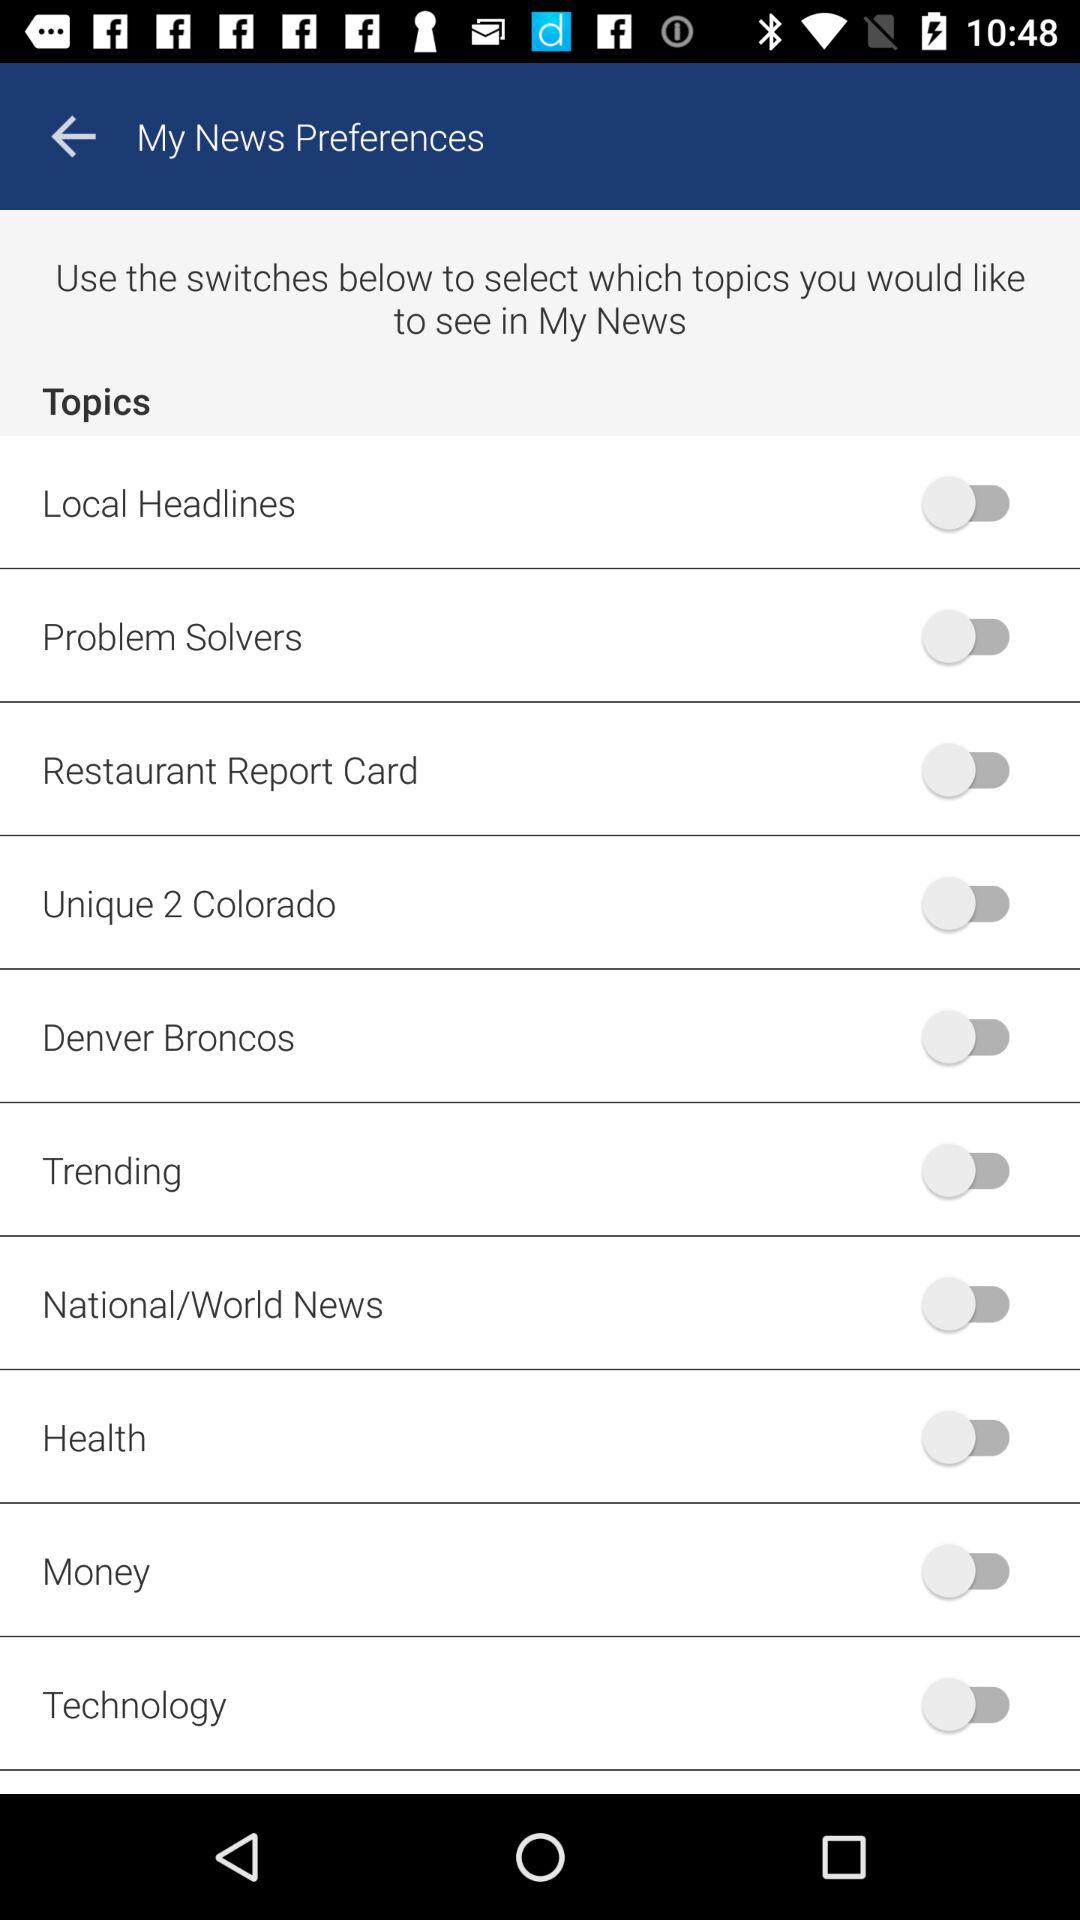What is the current status of "Health"? The current status is "off". 